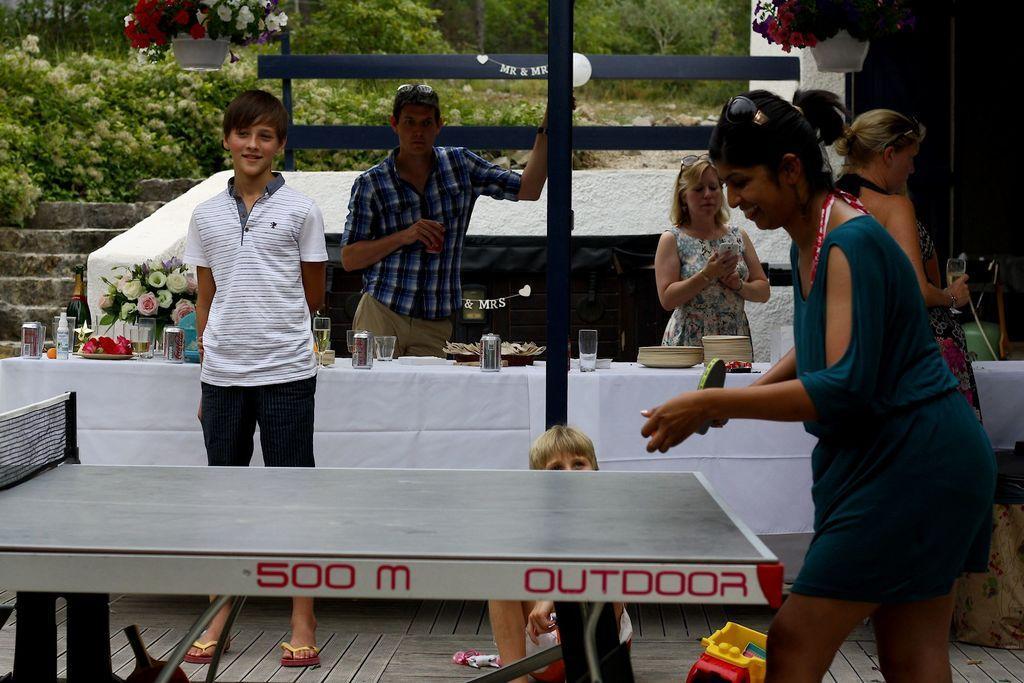How would you summarize this image in a sentence or two? In this picture we can see two men and three woman standing and they are smiling and in front of them on table we have tin, glasses, plate, vase with flowers and in background we can see steps, trees, wooden plank and in front woman is playing table tennis. 